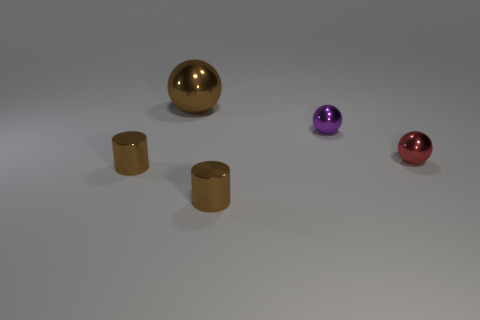Add 5 metallic cylinders. How many objects exist? 10 Subtract all balls. How many objects are left? 2 Add 4 tiny metallic objects. How many tiny metallic objects exist? 8 Subtract 0 cyan cylinders. How many objects are left? 5 Subtract all brown metal cylinders. Subtract all metallic balls. How many objects are left? 0 Add 5 big brown shiny spheres. How many big brown shiny spheres are left? 6 